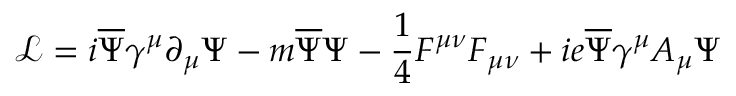Convert formula to latex. <formula><loc_0><loc_0><loc_500><loc_500>{ \mathcal { L } } = i { \overline { \Psi } } \gamma ^ { \mu } \partial _ { \mu } \Psi - m { \overline { \Psi } } \Psi - \frac { 1 } { 4 } F ^ { \mu \nu } F _ { \mu \nu } + i e \overline { \Psi } { \gamma ^ { \mu } } { A _ { \mu } } { \Psi }</formula> 